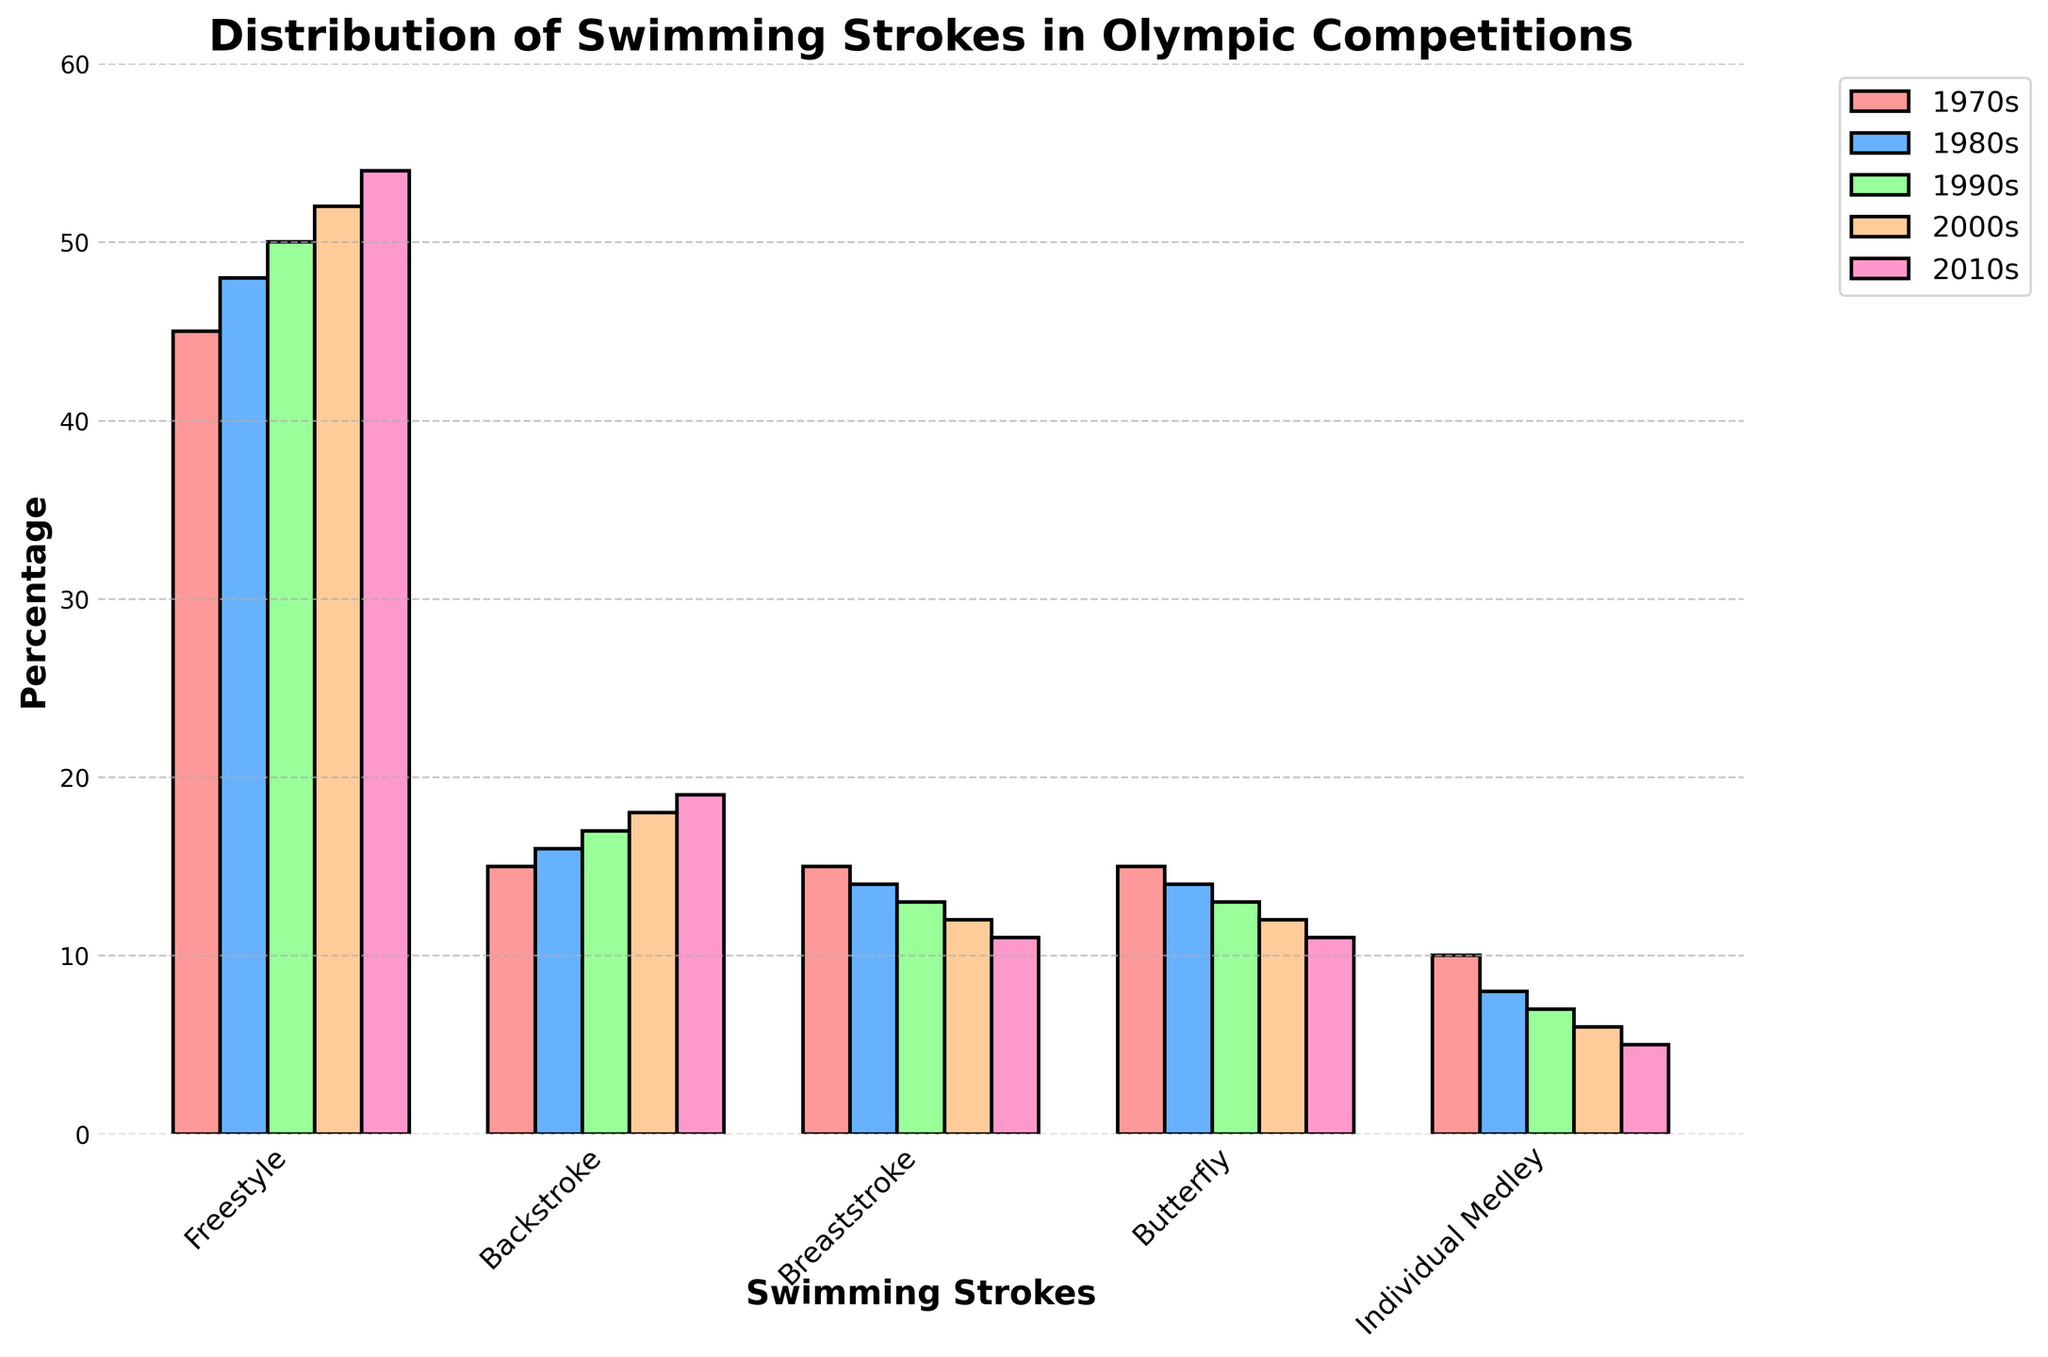What's the most frequently used swimming stroke in the 2010s? By observing the height of the bars on the chart, the Freestyle stroke has the tallest bar in the 2010s, indicating it's the most frequently used.
Answer: Freestyle Which stroke shows a consistent decrease in usage every decade? By examining the trend of each stroke over the decades, both Breaststroke and Butterfly show a consistent decline. However, Individual Medley shows a continuous decrease from 1970s to 2010s.
Answer: Individual Medley Which decade shows the highest usage of Backstroke? The highest bar for Backstroke corresponds to the 2010s.
Answer: 2010s What is the percentage difference in usage between Freestyle and Butterfly in the 1990s? The bar heights for Freestyle and Butterfly in the 1990s are 50 and 13, respectively. The difference is 50 - 13 = 37.
Answer: 37 Comparing the 1970s and 2010s, which stroke experienced the greatest decrease in usage? By looking at the difference in bar heights for each stroke between the 1970s and 2010s, Individual Medley reduced from 10% to 5%, which is a decrease of 5%. This is the greatest decrease among all strokes.
Answer: Individual Medley Which stroke has nearly equal usage in the 1980s and 1990s? By comparing the bar heights, the Backstroke stroke has values 16 (1980s) and 17 (1990s), which are very close to each other.
Answer: Backstroke What's the total percentage usage of the Breaststroke in the 1970s and 1980s combined? The bar heights for Breaststroke in the 1970s and 1980s are 15 and 14, respectively. The total is 15 + 14 = 29.
Answer: 29 How has the usage of Freestyle changed from the 1970s to the 2000s? The bar heights for Freestyle in the 1970s and 2000s are 45 and 52 respectively. The increase is 52 - 45 = 7.
Answer: Increased by 7 Which stroke is visually represented using the green color in the figure? From the visual cue in the question, the bar color for the Individual Medley is green.
Answer: Individual Medley 